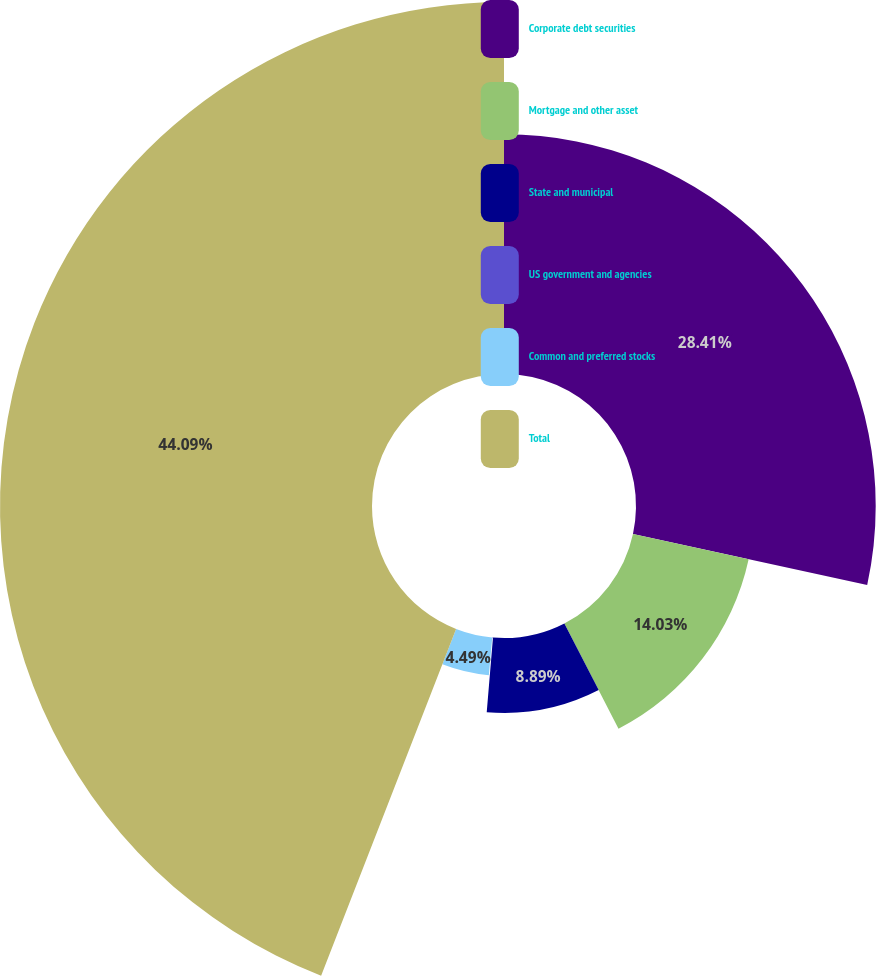Convert chart. <chart><loc_0><loc_0><loc_500><loc_500><pie_chart><fcel>Corporate debt securities<fcel>Mortgage and other asset<fcel>State and municipal<fcel>US government and agencies<fcel>Common and preferred stocks<fcel>Total<nl><fcel>28.41%<fcel>14.03%<fcel>8.89%<fcel>0.09%<fcel>4.49%<fcel>44.09%<nl></chart> 